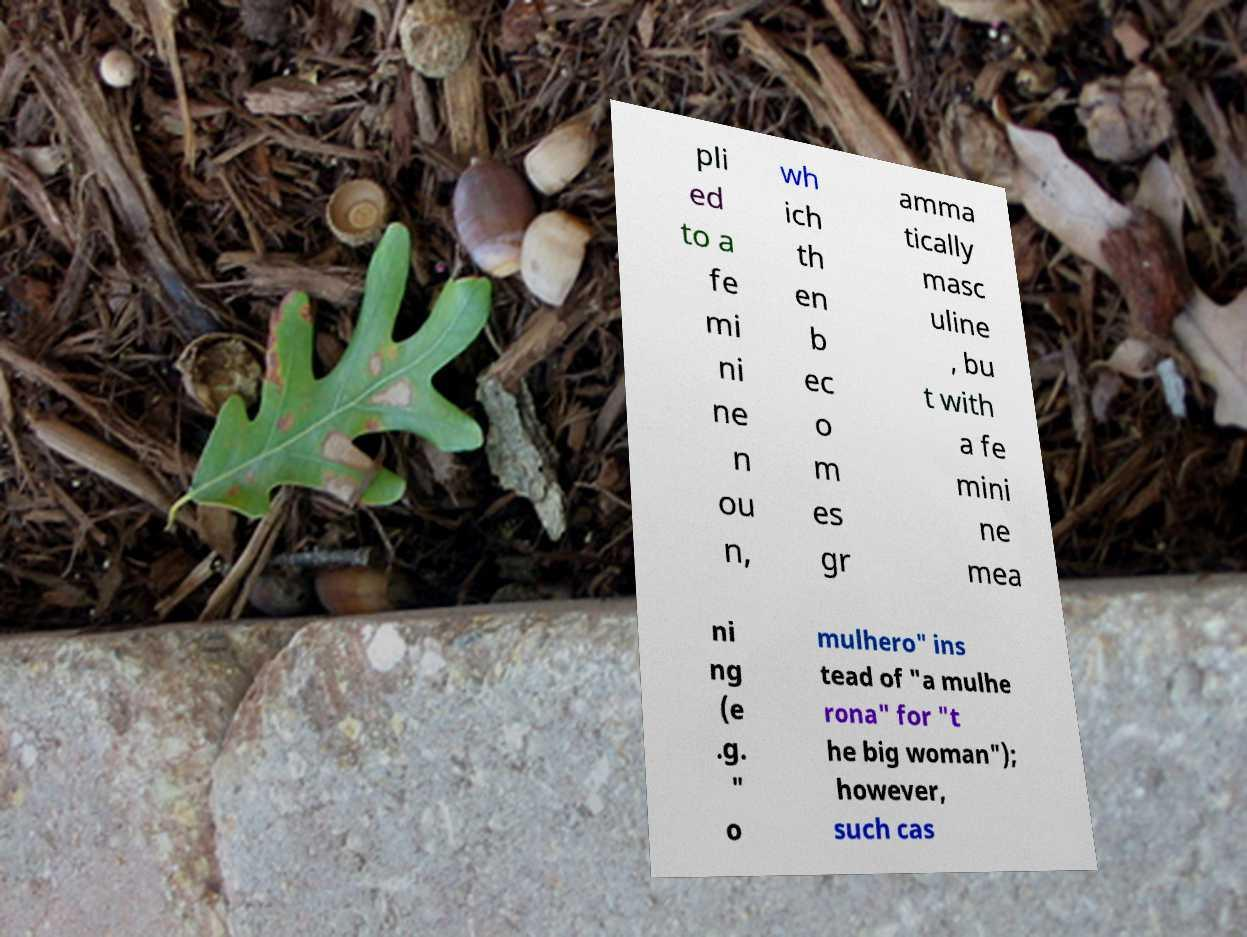Can you read and provide the text displayed in the image?This photo seems to have some interesting text. Can you extract and type it out for me? pli ed to a fe mi ni ne n ou n, wh ich th en b ec o m es gr amma tically masc uline , bu t with a fe mini ne mea ni ng (e .g. " o mulhero" ins tead of "a mulhe rona" for "t he big woman"); however, such cas 